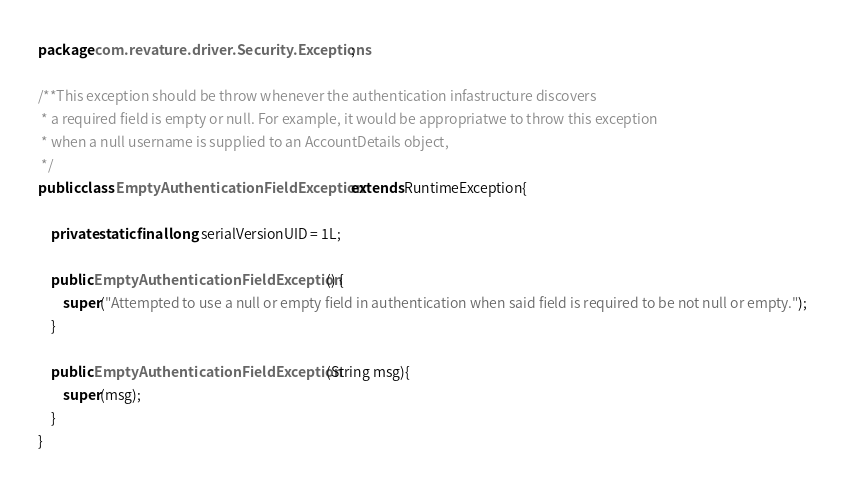<code> <loc_0><loc_0><loc_500><loc_500><_Java_>package com.revature.driver.Security.Exceptions;

/**This exception should be throw whenever the authentication infastructure discovers 
 * a required field is empty or null. For example, it would be appropriatwe to throw this exception 
 * when a null username is supplied to an AccountDetails object,
 */
public class EmptyAuthenticationFieldException extends RuntimeException{

    private static final long serialVersionUID = 1L;

    public EmptyAuthenticationFieldException() {
        super("Attempted to use a null or empty field in authentication when said field is required to be not null or empty.");
    }

    public EmptyAuthenticationFieldException(String msg){
        super(msg);
    }
}
</code> 